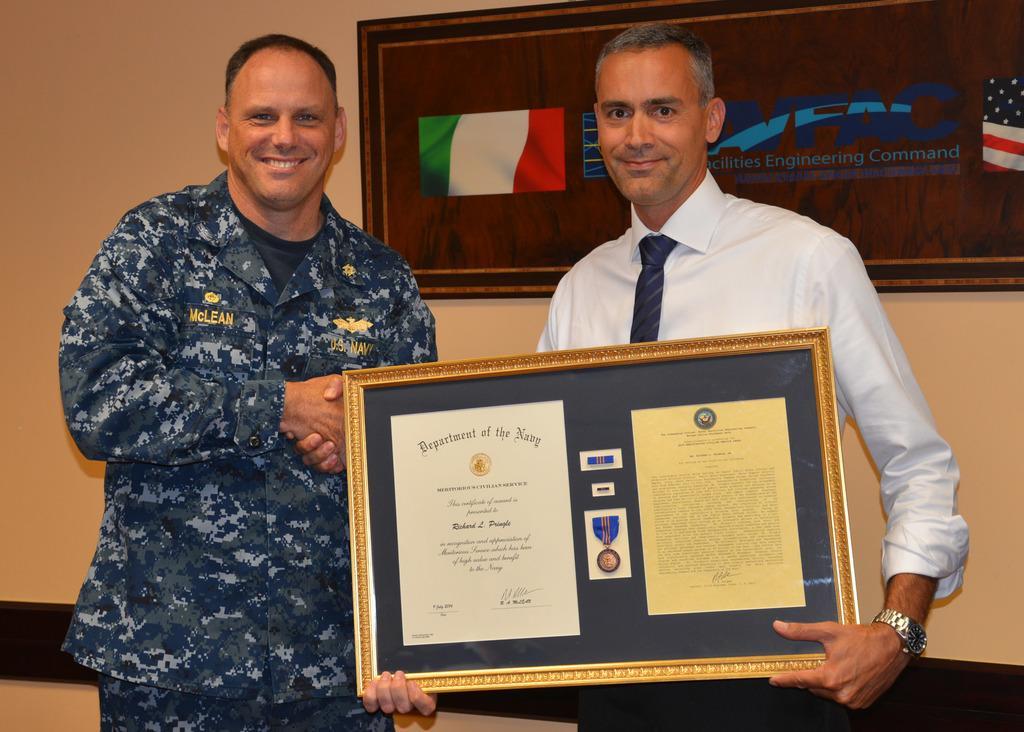Please provide a concise description of this image. In this picture we can see two men smiling where a man is holding a frame with his hands and in the background we can see a board on the wall. 